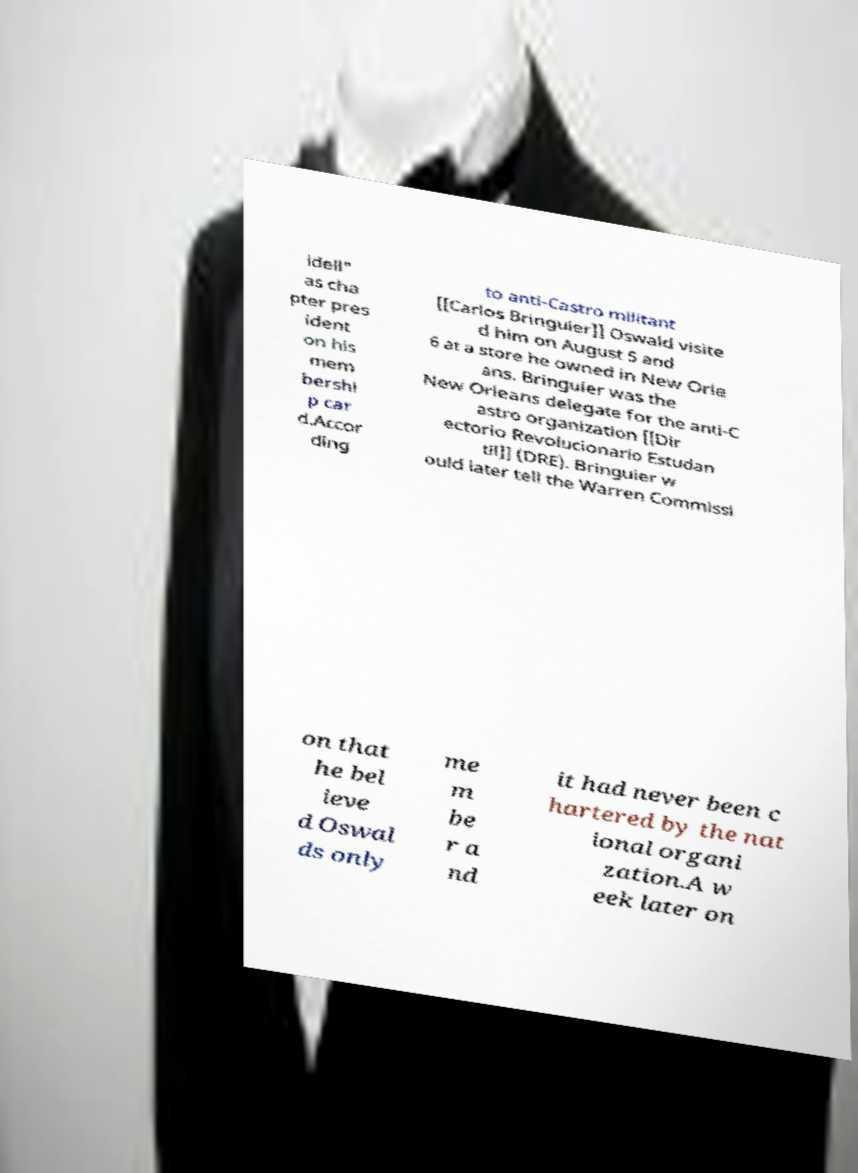I need the written content from this picture converted into text. Can you do that? idell" as cha pter pres ident on his mem bershi p car d.Accor ding to anti-Castro militant [[Carlos Bringuier]] Oswald visite d him on August 5 and 6 at a store he owned in New Orle ans. Bringuier was the New Orleans delegate for the anti-C astro organization [[Dir ectorio Revolucionario Estudan til]] (DRE). Bringuier w ould later tell the Warren Commissi on that he bel ieve d Oswal ds only me m be r a nd it had never been c hartered by the nat ional organi zation.A w eek later on 